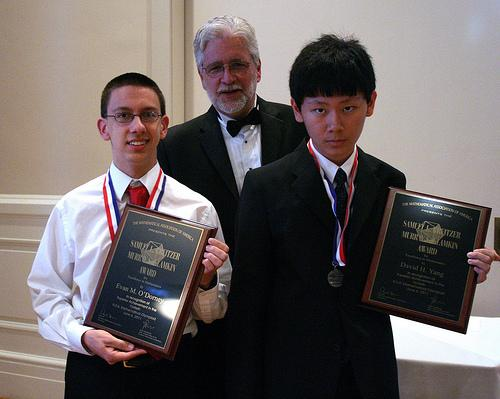In what type of attire is the older gentleman behind the young men dressed? The older gentleman is wearing a tuxedo. Can you tell me the dominating color of the wall in the background of the image? The dominating color of the wall in the background is cream. What color is the tablecloth on the table in the image? The tablecloth on the table is white. Analyze the interaction between the objects in the image. The two boys and the older man appear to be posing together for a photo, with the boys holding their awards and wearing their medals, and the man's arms around their shoulders. Identify the three primary colors in the medal hanging around the boy's neck. The primary colors of the medal are blue, red, and white. Assess the image quality based on the given details. The image quality is detailed and clear, with precise object detection and specific features, such as colors, hair, and clothing. Provide a brief description of the boys holding awards in the image. The boys holding awards are one in a white long sleeve shirt and one in a black suit, with medals around their necks. How would you describe the mood and sentiment of the image? The image has a positive and accomplished sentiment, depicting a proud moment for two boys with awards and an older man. What objects can be seen in the image, and how many of each type? Objects: 3 people, 2 awards, 2 medals, 1 man's black bow tie, 1 wooden plaque, 1 table, 1 white tablecloth, 1 cream-colored wall, white wainscoating. Which specific item is the boy on the right hiding behind his plaque? The boy on the right is hiding a medal behind his plaque. Is the old man wearing a purple bow tie? The image information specifies that the older man is wearing a "black bow tie." Suggesting that it is purple instead is misleading. Is there a green tablecloth on the table behind the man and the two boys? The image information mentions a "white table cloth" on the table. Suggesting that it is green instead is misleading. Is the boy on the right wearing a green suit? The image information mentions that the boy on the right is wearing a "black suit," not a green suit. Suggesting the color is different is misleading. Are both boys wearing a cap in the image? The image information talks about both boys having hair, with one having "short hair" while the other has "black hair." There is no mention of them wearing any caps. Suggesting that they are wearing caps is misleading. Is there a yellow ribbon around the left man's neck? The image information mentions a "ribbon around left man's neck" but it does not mention the color. Since it does not provide color information, suggesting the color is yellow is misleading. Does the boy on the left have long hair reaching his shoulders? The image information mentions that the boy on the left has "short hair." Suggesting that he has long hair is misleading. 